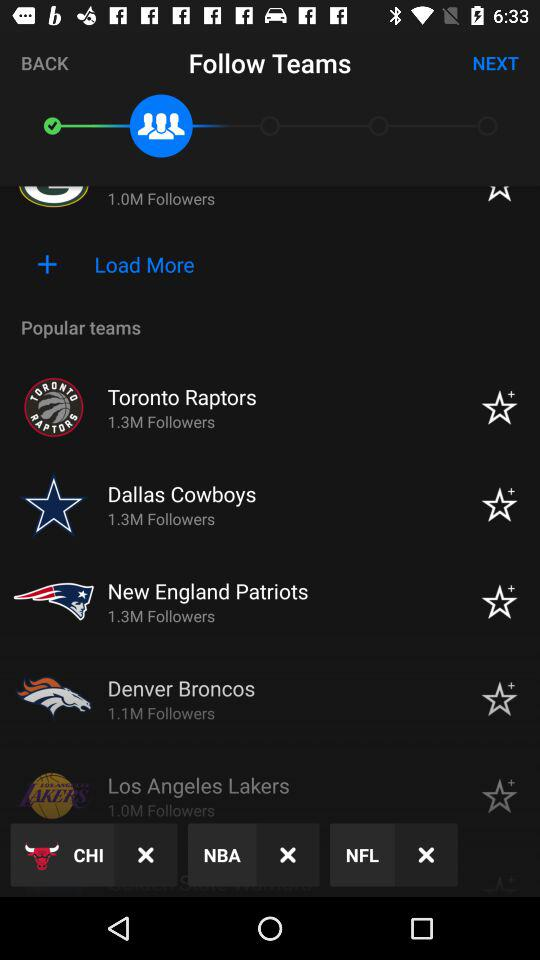How many followers are there of the Denver Broncos? There are 1.1 million followers of the Denver Broncos. 